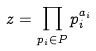<formula> <loc_0><loc_0><loc_500><loc_500>z = \prod _ { p _ { i } \in P } p _ { i } ^ { a _ { i } }</formula> 